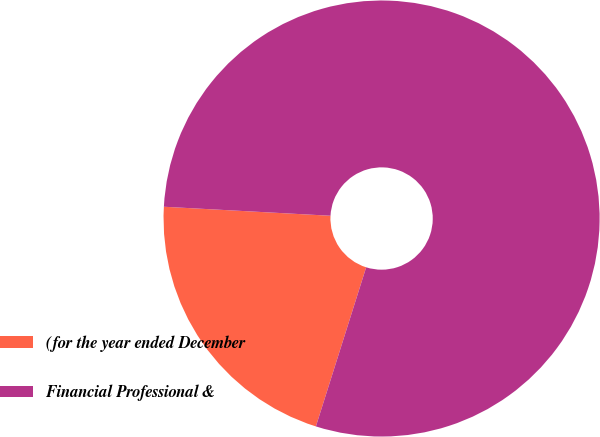Convert chart. <chart><loc_0><loc_0><loc_500><loc_500><pie_chart><fcel>(for the year ended December<fcel>Financial Professional &<nl><fcel>20.99%<fcel>79.01%<nl></chart> 